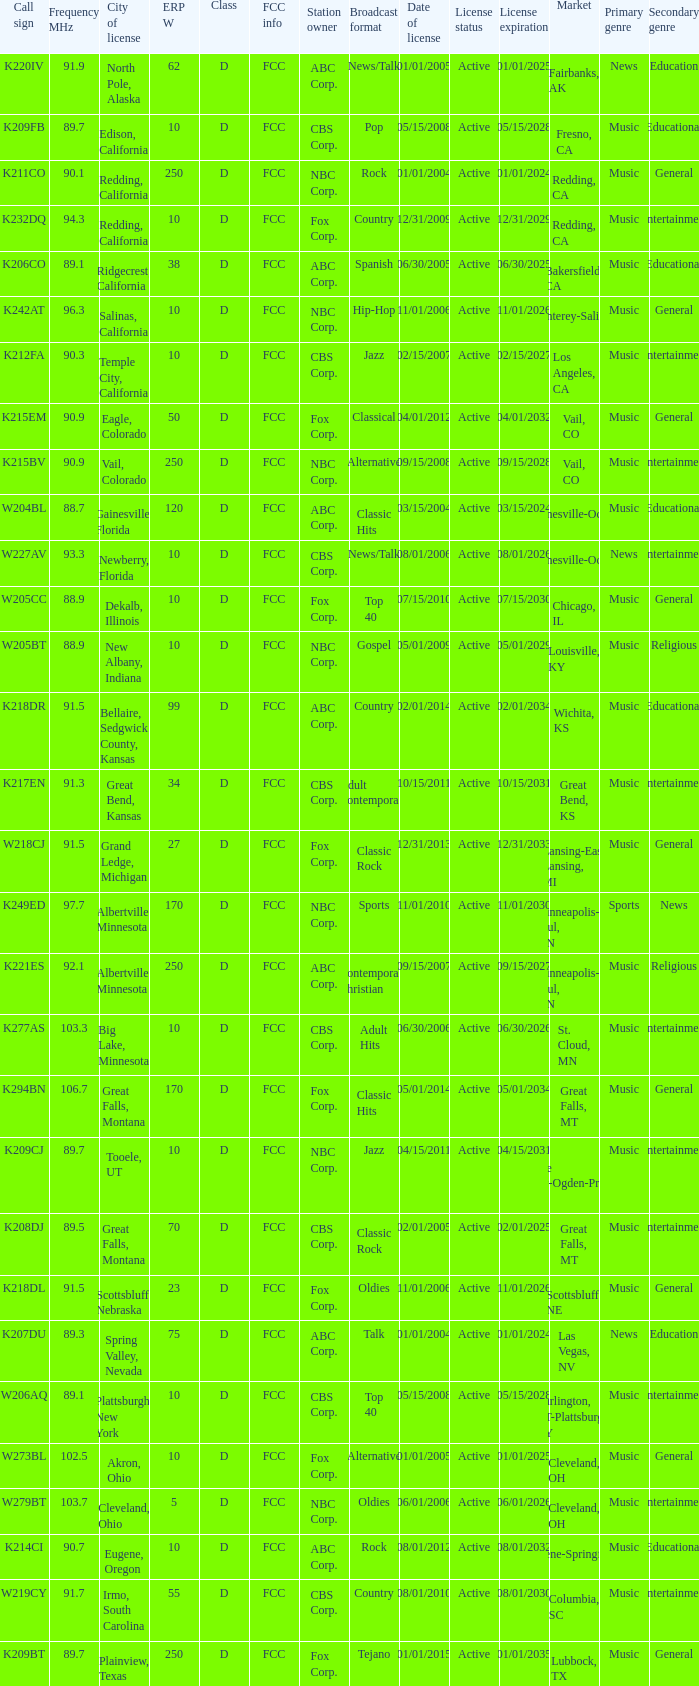What is the FCC info of the translator with an Irmo, South Carolina city license? FCC. 